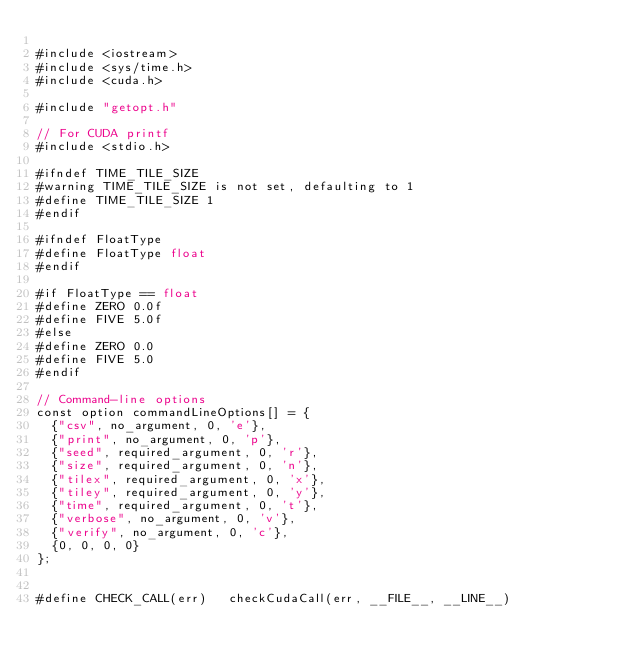Convert code to text. <code><loc_0><loc_0><loc_500><loc_500><_Cuda_>
#include <iostream>
#include <sys/time.h>
#include <cuda.h>

#include "getopt.h"

// For CUDA printf
#include <stdio.h>

#ifndef TIME_TILE_SIZE
#warning TIME_TILE_SIZE is not set, defaulting to 1
#define TIME_TILE_SIZE 1
#endif

#ifndef FloatType
#define FloatType float
#endif

#if FloatType == float
#define ZERO 0.0f
#define FIVE 5.0f
#else
#define ZERO 0.0
#define FIVE 5.0
#endif

// Command-line options
const option commandLineOptions[] = {
  {"csv", no_argument, 0, 'e'},
  {"print", no_argument, 0, 'p'},
  {"seed", required_argument, 0, 'r'},
  {"size", required_argument, 0, 'n'},
  {"tilex", required_argument, 0, 'x'},
  {"tiley", required_argument, 0, 'y'},
  {"time", required_argument, 0, 't'},
  {"verbose", no_argument, 0, 'v'},
  {"verify", no_argument, 0, 'c'},
  {0, 0, 0, 0}
};


#define CHECK_CALL(err)   checkCudaCall(err, __FILE__, __LINE__)</code> 